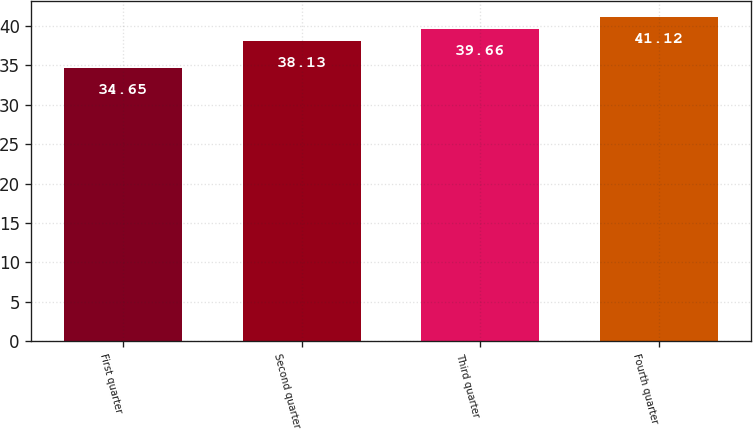<chart> <loc_0><loc_0><loc_500><loc_500><bar_chart><fcel>First quarter<fcel>Second quarter<fcel>Third quarter<fcel>Fourth quarter<nl><fcel>34.65<fcel>38.13<fcel>39.66<fcel>41.12<nl></chart> 